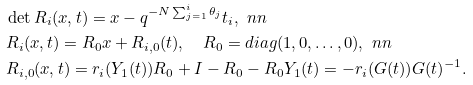Convert formula to latex. <formula><loc_0><loc_0><loc_500><loc_500>& \det R _ { i } ( x , t ) = x - q ^ { - N \sum _ { j = 1 } ^ { i } \theta _ { j } } t _ { i } , \ n n \\ & R _ { i } ( x , t ) = R _ { 0 } x + R _ { i , 0 } ( t ) , \quad R _ { 0 } = d i a g ( 1 , 0 , \dots , 0 ) , \ n n \\ & R _ { i , 0 } ( x , t ) = r _ { i } ( Y _ { 1 } ( t ) ) R _ { 0 } + I - R _ { 0 } - R _ { 0 } Y _ { 1 } ( t ) = - r _ { i } ( G ( t ) ) G ( t ) ^ { - 1 } .</formula> 